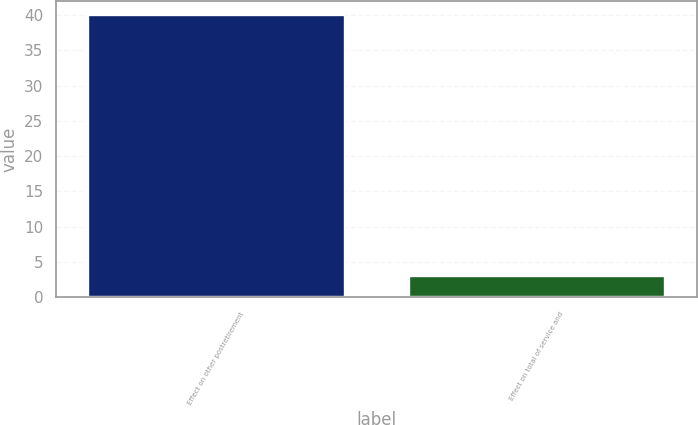Convert chart. <chart><loc_0><loc_0><loc_500><loc_500><bar_chart><fcel>Effect on other postretirement<fcel>Effect on total of service and<nl><fcel>40<fcel>3<nl></chart> 